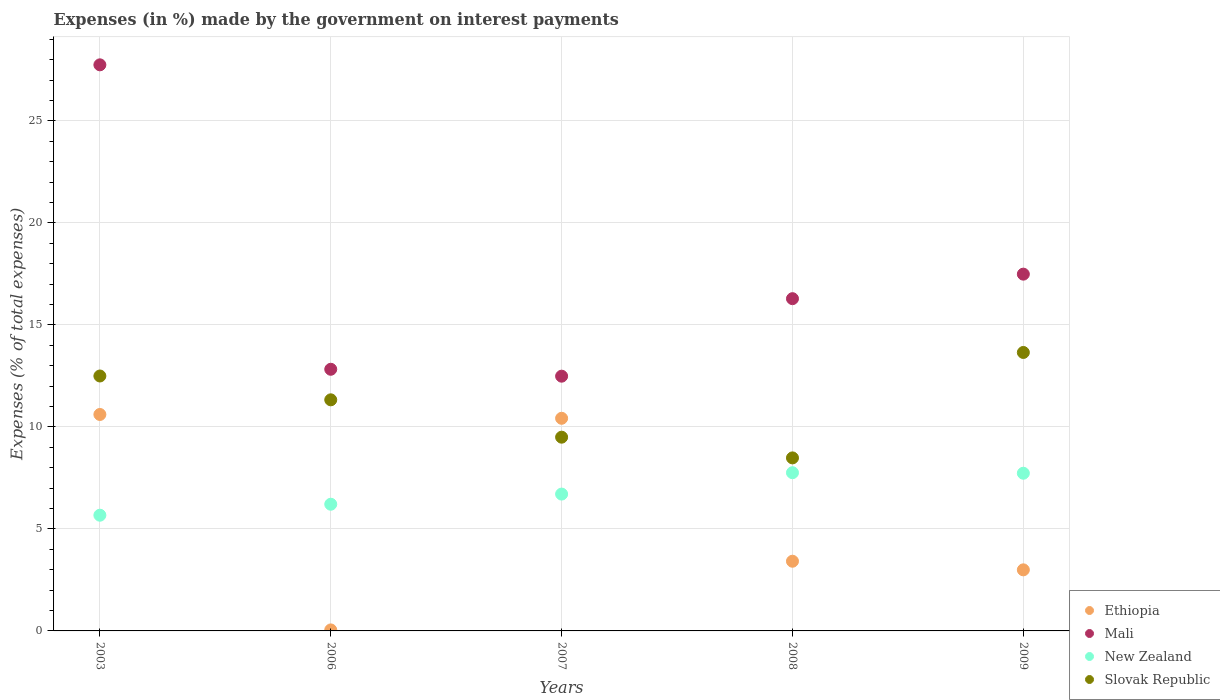What is the percentage of expenses made by the government on interest payments in New Zealand in 2003?
Offer a very short reply. 5.67. Across all years, what is the maximum percentage of expenses made by the government on interest payments in Slovak Republic?
Provide a short and direct response. 13.65. Across all years, what is the minimum percentage of expenses made by the government on interest payments in Mali?
Your answer should be very brief. 12.49. In which year was the percentage of expenses made by the government on interest payments in Slovak Republic maximum?
Give a very brief answer. 2009. What is the total percentage of expenses made by the government on interest payments in Ethiopia in the graph?
Give a very brief answer. 27.49. What is the difference between the percentage of expenses made by the government on interest payments in Ethiopia in 2003 and that in 2007?
Your response must be concise. 0.19. What is the difference between the percentage of expenses made by the government on interest payments in Slovak Republic in 2006 and the percentage of expenses made by the government on interest payments in Ethiopia in 2009?
Your response must be concise. 8.33. What is the average percentage of expenses made by the government on interest payments in Mali per year?
Offer a terse response. 17.37. In the year 2008, what is the difference between the percentage of expenses made by the government on interest payments in Slovak Republic and percentage of expenses made by the government on interest payments in Mali?
Make the answer very short. -7.8. In how many years, is the percentage of expenses made by the government on interest payments in Slovak Republic greater than 25 %?
Offer a terse response. 0. What is the ratio of the percentage of expenses made by the government on interest payments in Ethiopia in 2007 to that in 2009?
Your answer should be compact. 3.48. Is the percentage of expenses made by the government on interest payments in Ethiopia in 2007 less than that in 2009?
Your answer should be very brief. No. Is the difference between the percentage of expenses made by the government on interest payments in Slovak Republic in 2006 and 2008 greater than the difference between the percentage of expenses made by the government on interest payments in Mali in 2006 and 2008?
Your answer should be very brief. Yes. What is the difference between the highest and the second highest percentage of expenses made by the government on interest payments in New Zealand?
Ensure brevity in your answer.  0.03. What is the difference between the highest and the lowest percentage of expenses made by the government on interest payments in New Zealand?
Your response must be concise. 2.08. In how many years, is the percentage of expenses made by the government on interest payments in Mali greater than the average percentage of expenses made by the government on interest payments in Mali taken over all years?
Offer a terse response. 2. Is the sum of the percentage of expenses made by the government on interest payments in Ethiopia in 2003 and 2008 greater than the maximum percentage of expenses made by the government on interest payments in Mali across all years?
Your answer should be very brief. No. Is the percentage of expenses made by the government on interest payments in Ethiopia strictly less than the percentage of expenses made by the government on interest payments in Mali over the years?
Provide a short and direct response. Yes. How many years are there in the graph?
Your answer should be very brief. 5. Does the graph contain any zero values?
Ensure brevity in your answer.  No. What is the title of the graph?
Keep it short and to the point. Expenses (in %) made by the government on interest payments. Does "Low & middle income" appear as one of the legend labels in the graph?
Keep it short and to the point. No. What is the label or title of the Y-axis?
Offer a very short reply. Expenses (% of total expenses). What is the Expenses (% of total expenses) in Ethiopia in 2003?
Make the answer very short. 10.61. What is the Expenses (% of total expenses) of Mali in 2003?
Provide a succinct answer. 27.75. What is the Expenses (% of total expenses) in New Zealand in 2003?
Your answer should be compact. 5.67. What is the Expenses (% of total expenses) in Slovak Republic in 2003?
Offer a very short reply. 12.49. What is the Expenses (% of total expenses) of Ethiopia in 2006?
Give a very brief answer. 0.05. What is the Expenses (% of total expenses) of Mali in 2006?
Your response must be concise. 12.82. What is the Expenses (% of total expenses) in New Zealand in 2006?
Make the answer very short. 6.21. What is the Expenses (% of total expenses) in Slovak Republic in 2006?
Your response must be concise. 11.33. What is the Expenses (% of total expenses) in Ethiopia in 2007?
Provide a short and direct response. 10.42. What is the Expenses (% of total expenses) of Mali in 2007?
Ensure brevity in your answer.  12.49. What is the Expenses (% of total expenses) in New Zealand in 2007?
Offer a very short reply. 6.71. What is the Expenses (% of total expenses) in Slovak Republic in 2007?
Keep it short and to the point. 9.5. What is the Expenses (% of total expenses) in Ethiopia in 2008?
Your answer should be compact. 3.42. What is the Expenses (% of total expenses) in Mali in 2008?
Your response must be concise. 16.28. What is the Expenses (% of total expenses) of New Zealand in 2008?
Offer a very short reply. 7.75. What is the Expenses (% of total expenses) in Slovak Republic in 2008?
Your answer should be compact. 8.48. What is the Expenses (% of total expenses) in Ethiopia in 2009?
Offer a very short reply. 2.99. What is the Expenses (% of total expenses) in Mali in 2009?
Provide a short and direct response. 17.49. What is the Expenses (% of total expenses) of New Zealand in 2009?
Provide a short and direct response. 7.73. What is the Expenses (% of total expenses) in Slovak Republic in 2009?
Your answer should be very brief. 13.65. Across all years, what is the maximum Expenses (% of total expenses) in Ethiopia?
Make the answer very short. 10.61. Across all years, what is the maximum Expenses (% of total expenses) in Mali?
Provide a short and direct response. 27.75. Across all years, what is the maximum Expenses (% of total expenses) in New Zealand?
Give a very brief answer. 7.75. Across all years, what is the maximum Expenses (% of total expenses) in Slovak Republic?
Offer a terse response. 13.65. Across all years, what is the minimum Expenses (% of total expenses) in Ethiopia?
Ensure brevity in your answer.  0.05. Across all years, what is the minimum Expenses (% of total expenses) in Mali?
Make the answer very short. 12.49. Across all years, what is the minimum Expenses (% of total expenses) in New Zealand?
Offer a terse response. 5.67. Across all years, what is the minimum Expenses (% of total expenses) in Slovak Republic?
Keep it short and to the point. 8.48. What is the total Expenses (% of total expenses) of Ethiopia in the graph?
Offer a very short reply. 27.49. What is the total Expenses (% of total expenses) in Mali in the graph?
Your response must be concise. 86.83. What is the total Expenses (% of total expenses) of New Zealand in the graph?
Make the answer very short. 34.07. What is the total Expenses (% of total expenses) in Slovak Republic in the graph?
Provide a short and direct response. 55.44. What is the difference between the Expenses (% of total expenses) in Ethiopia in 2003 and that in 2006?
Your response must be concise. 10.56. What is the difference between the Expenses (% of total expenses) in Mali in 2003 and that in 2006?
Make the answer very short. 14.92. What is the difference between the Expenses (% of total expenses) in New Zealand in 2003 and that in 2006?
Offer a very short reply. -0.54. What is the difference between the Expenses (% of total expenses) in Slovak Republic in 2003 and that in 2006?
Your response must be concise. 1.17. What is the difference between the Expenses (% of total expenses) of Ethiopia in 2003 and that in 2007?
Offer a very short reply. 0.19. What is the difference between the Expenses (% of total expenses) in Mali in 2003 and that in 2007?
Your answer should be compact. 15.26. What is the difference between the Expenses (% of total expenses) of New Zealand in 2003 and that in 2007?
Provide a succinct answer. -1.04. What is the difference between the Expenses (% of total expenses) of Slovak Republic in 2003 and that in 2007?
Keep it short and to the point. 3. What is the difference between the Expenses (% of total expenses) of Ethiopia in 2003 and that in 2008?
Offer a very short reply. 7.19. What is the difference between the Expenses (% of total expenses) of Mali in 2003 and that in 2008?
Offer a terse response. 11.46. What is the difference between the Expenses (% of total expenses) of New Zealand in 2003 and that in 2008?
Your response must be concise. -2.08. What is the difference between the Expenses (% of total expenses) of Slovak Republic in 2003 and that in 2008?
Offer a very short reply. 4.01. What is the difference between the Expenses (% of total expenses) of Ethiopia in 2003 and that in 2009?
Keep it short and to the point. 7.62. What is the difference between the Expenses (% of total expenses) of Mali in 2003 and that in 2009?
Your response must be concise. 10.26. What is the difference between the Expenses (% of total expenses) in New Zealand in 2003 and that in 2009?
Your answer should be very brief. -2.06. What is the difference between the Expenses (% of total expenses) of Slovak Republic in 2003 and that in 2009?
Offer a very short reply. -1.15. What is the difference between the Expenses (% of total expenses) of Ethiopia in 2006 and that in 2007?
Provide a short and direct response. -10.37. What is the difference between the Expenses (% of total expenses) in Mali in 2006 and that in 2007?
Make the answer very short. 0.34. What is the difference between the Expenses (% of total expenses) in New Zealand in 2006 and that in 2007?
Give a very brief answer. -0.5. What is the difference between the Expenses (% of total expenses) of Slovak Republic in 2006 and that in 2007?
Your response must be concise. 1.83. What is the difference between the Expenses (% of total expenses) in Ethiopia in 2006 and that in 2008?
Keep it short and to the point. -3.37. What is the difference between the Expenses (% of total expenses) in Mali in 2006 and that in 2008?
Your response must be concise. -3.46. What is the difference between the Expenses (% of total expenses) of New Zealand in 2006 and that in 2008?
Ensure brevity in your answer.  -1.55. What is the difference between the Expenses (% of total expenses) of Slovak Republic in 2006 and that in 2008?
Offer a very short reply. 2.85. What is the difference between the Expenses (% of total expenses) of Ethiopia in 2006 and that in 2009?
Your answer should be compact. -2.94. What is the difference between the Expenses (% of total expenses) in Mali in 2006 and that in 2009?
Keep it short and to the point. -4.66. What is the difference between the Expenses (% of total expenses) of New Zealand in 2006 and that in 2009?
Keep it short and to the point. -1.52. What is the difference between the Expenses (% of total expenses) in Slovak Republic in 2006 and that in 2009?
Your answer should be very brief. -2.32. What is the difference between the Expenses (% of total expenses) of Ethiopia in 2007 and that in 2008?
Offer a terse response. 7.01. What is the difference between the Expenses (% of total expenses) in Mali in 2007 and that in 2008?
Provide a succinct answer. -3.8. What is the difference between the Expenses (% of total expenses) of New Zealand in 2007 and that in 2008?
Your answer should be very brief. -1.05. What is the difference between the Expenses (% of total expenses) in Ethiopia in 2007 and that in 2009?
Your answer should be very brief. 7.43. What is the difference between the Expenses (% of total expenses) in Mali in 2007 and that in 2009?
Make the answer very short. -5. What is the difference between the Expenses (% of total expenses) of New Zealand in 2007 and that in 2009?
Ensure brevity in your answer.  -1.02. What is the difference between the Expenses (% of total expenses) of Slovak Republic in 2007 and that in 2009?
Give a very brief answer. -4.15. What is the difference between the Expenses (% of total expenses) in Ethiopia in 2008 and that in 2009?
Make the answer very short. 0.42. What is the difference between the Expenses (% of total expenses) in Mali in 2008 and that in 2009?
Your answer should be compact. -1.2. What is the difference between the Expenses (% of total expenses) of New Zealand in 2008 and that in 2009?
Make the answer very short. 0.03. What is the difference between the Expenses (% of total expenses) in Slovak Republic in 2008 and that in 2009?
Offer a terse response. -5.17. What is the difference between the Expenses (% of total expenses) in Ethiopia in 2003 and the Expenses (% of total expenses) in Mali in 2006?
Offer a terse response. -2.22. What is the difference between the Expenses (% of total expenses) of Ethiopia in 2003 and the Expenses (% of total expenses) of New Zealand in 2006?
Offer a terse response. 4.4. What is the difference between the Expenses (% of total expenses) in Ethiopia in 2003 and the Expenses (% of total expenses) in Slovak Republic in 2006?
Offer a terse response. -0.72. What is the difference between the Expenses (% of total expenses) of Mali in 2003 and the Expenses (% of total expenses) of New Zealand in 2006?
Keep it short and to the point. 21.54. What is the difference between the Expenses (% of total expenses) in Mali in 2003 and the Expenses (% of total expenses) in Slovak Republic in 2006?
Your answer should be very brief. 16.42. What is the difference between the Expenses (% of total expenses) in New Zealand in 2003 and the Expenses (% of total expenses) in Slovak Republic in 2006?
Make the answer very short. -5.66. What is the difference between the Expenses (% of total expenses) in Ethiopia in 2003 and the Expenses (% of total expenses) in Mali in 2007?
Keep it short and to the point. -1.88. What is the difference between the Expenses (% of total expenses) in Ethiopia in 2003 and the Expenses (% of total expenses) in New Zealand in 2007?
Your answer should be compact. 3.9. What is the difference between the Expenses (% of total expenses) of Ethiopia in 2003 and the Expenses (% of total expenses) of Slovak Republic in 2007?
Offer a terse response. 1.11. What is the difference between the Expenses (% of total expenses) in Mali in 2003 and the Expenses (% of total expenses) in New Zealand in 2007?
Offer a very short reply. 21.04. What is the difference between the Expenses (% of total expenses) in Mali in 2003 and the Expenses (% of total expenses) in Slovak Republic in 2007?
Offer a very short reply. 18.25. What is the difference between the Expenses (% of total expenses) of New Zealand in 2003 and the Expenses (% of total expenses) of Slovak Republic in 2007?
Offer a terse response. -3.82. What is the difference between the Expenses (% of total expenses) of Ethiopia in 2003 and the Expenses (% of total expenses) of Mali in 2008?
Your response must be concise. -5.68. What is the difference between the Expenses (% of total expenses) in Ethiopia in 2003 and the Expenses (% of total expenses) in New Zealand in 2008?
Your answer should be compact. 2.85. What is the difference between the Expenses (% of total expenses) of Ethiopia in 2003 and the Expenses (% of total expenses) of Slovak Republic in 2008?
Keep it short and to the point. 2.13. What is the difference between the Expenses (% of total expenses) of Mali in 2003 and the Expenses (% of total expenses) of New Zealand in 2008?
Your answer should be compact. 19.99. What is the difference between the Expenses (% of total expenses) in Mali in 2003 and the Expenses (% of total expenses) in Slovak Republic in 2008?
Ensure brevity in your answer.  19.27. What is the difference between the Expenses (% of total expenses) of New Zealand in 2003 and the Expenses (% of total expenses) of Slovak Republic in 2008?
Your answer should be compact. -2.81. What is the difference between the Expenses (% of total expenses) in Ethiopia in 2003 and the Expenses (% of total expenses) in Mali in 2009?
Provide a succinct answer. -6.88. What is the difference between the Expenses (% of total expenses) in Ethiopia in 2003 and the Expenses (% of total expenses) in New Zealand in 2009?
Offer a very short reply. 2.88. What is the difference between the Expenses (% of total expenses) of Ethiopia in 2003 and the Expenses (% of total expenses) of Slovak Republic in 2009?
Provide a short and direct response. -3.04. What is the difference between the Expenses (% of total expenses) in Mali in 2003 and the Expenses (% of total expenses) in New Zealand in 2009?
Your answer should be very brief. 20.02. What is the difference between the Expenses (% of total expenses) in Mali in 2003 and the Expenses (% of total expenses) in Slovak Republic in 2009?
Keep it short and to the point. 14.1. What is the difference between the Expenses (% of total expenses) in New Zealand in 2003 and the Expenses (% of total expenses) in Slovak Republic in 2009?
Offer a very short reply. -7.98. What is the difference between the Expenses (% of total expenses) in Ethiopia in 2006 and the Expenses (% of total expenses) in Mali in 2007?
Your answer should be compact. -12.44. What is the difference between the Expenses (% of total expenses) of Ethiopia in 2006 and the Expenses (% of total expenses) of New Zealand in 2007?
Keep it short and to the point. -6.66. What is the difference between the Expenses (% of total expenses) in Ethiopia in 2006 and the Expenses (% of total expenses) in Slovak Republic in 2007?
Your response must be concise. -9.45. What is the difference between the Expenses (% of total expenses) in Mali in 2006 and the Expenses (% of total expenses) in New Zealand in 2007?
Your answer should be very brief. 6.12. What is the difference between the Expenses (% of total expenses) of Mali in 2006 and the Expenses (% of total expenses) of Slovak Republic in 2007?
Your response must be concise. 3.33. What is the difference between the Expenses (% of total expenses) in New Zealand in 2006 and the Expenses (% of total expenses) in Slovak Republic in 2007?
Offer a terse response. -3.29. What is the difference between the Expenses (% of total expenses) of Ethiopia in 2006 and the Expenses (% of total expenses) of Mali in 2008?
Provide a short and direct response. -16.23. What is the difference between the Expenses (% of total expenses) in Ethiopia in 2006 and the Expenses (% of total expenses) in New Zealand in 2008?
Provide a succinct answer. -7.71. What is the difference between the Expenses (% of total expenses) in Ethiopia in 2006 and the Expenses (% of total expenses) in Slovak Republic in 2008?
Provide a short and direct response. -8.43. What is the difference between the Expenses (% of total expenses) of Mali in 2006 and the Expenses (% of total expenses) of New Zealand in 2008?
Give a very brief answer. 5.07. What is the difference between the Expenses (% of total expenses) in Mali in 2006 and the Expenses (% of total expenses) in Slovak Republic in 2008?
Your answer should be very brief. 4.34. What is the difference between the Expenses (% of total expenses) of New Zealand in 2006 and the Expenses (% of total expenses) of Slovak Republic in 2008?
Keep it short and to the point. -2.27. What is the difference between the Expenses (% of total expenses) in Ethiopia in 2006 and the Expenses (% of total expenses) in Mali in 2009?
Provide a short and direct response. -17.44. What is the difference between the Expenses (% of total expenses) of Ethiopia in 2006 and the Expenses (% of total expenses) of New Zealand in 2009?
Offer a very short reply. -7.68. What is the difference between the Expenses (% of total expenses) of Ethiopia in 2006 and the Expenses (% of total expenses) of Slovak Republic in 2009?
Offer a very short reply. -13.6. What is the difference between the Expenses (% of total expenses) in Mali in 2006 and the Expenses (% of total expenses) in New Zealand in 2009?
Offer a very short reply. 5.1. What is the difference between the Expenses (% of total expenses) of Mali in 2006 and the Expenses (% of total expenses) of Slovak Republic in 2009?
Your answer should be very brief. -0.82. What is the difference between the Expenses (% of total expenses) in New Zealand in 2006 and the Expenses (% of total expenses) in Slovak Republic in 2009?
Keep it short and to the point. -7.44. What is the difference between the Expenses (% of total expenses) of Ethiopia in 2007 and the Expenses (% of total expenses) of Mali in 2008?
Give a very brief answer. -5.86. What is the difference between the Expenses (% of total expenses) in Ethiopia in 2007 and the Expenses (% of total expenses) in New Zealand in 2008?
Provide a succinct answer. 2.67. What is the difference between the Expenses (% of total expenses) in Ethiopia in 2007 and the Expenses (% of total expenses) in Slovak Republic in 2008?
Provide a succinct answer. 1.94. What is the difference between the Expenses (% of total expenses) of Mali in 2007 and the Expenses (% of total expenses) of New Zealand in 2008?
Give a very brief answer. 4.73. What is the difference between the Expenses (% of total expenses) of Mali in 2007 and the Expenses (% of total expenses) of Slovak Republic in 2008?
Provide a succinct answer. 4. What is the difference between the Expenses (% of total expenses) of New Zealand in 2007 and the Expenses (% of total expenses) of Slovak Republic in 2008?
Offer a terse response. -1.77. What is the difference between the Expenses (% of total expenses) of Ethiopia in 2007 and the Expenses (% of total expenses) of Mali in 2009?
Give a very brief answer. -7.06. What is the difference between the Expenses (% of total expenses) of Ethiopia in 2007 and the Expenses (% of total expenses) of New Zealand in 2009?
Offer a terse response. 2.69. What is the difference between the Expenses (% of total expenses) in Ethiopia in 2007 and the Expenses (% of total expenses) in Slovak Republic in 2009?
Your answer should be compact. -3.23. What is the difference between the Expenses (% of total expenses) of Mali in 2007 and the Expenses (% of total expenses) of New Zealand in 2009?
Your response must be concise. 4.76. What is the difference between the Expenses (% of total expenses) of Mali in 2007 and the Expenses (% of total expenses) of Slovak Republic in 2009?
Ensure brevity in your answer.  -1.16. What is the difference between the Expenses (% of total expenses) in New Zealand in 2007 and the Expenses (% of total expenses) in Slovak Republic in 2009?
Your answer should be compact. -6.94. What is the difference between the Expenses (% of total expenses) in Ethiopia in 2008 and the Expenses (% of total expenses) in Mali in 2009?
Your response must be concise. -14.07. What is the difference between the Expenses (% of total expenses) in Ethiopia in 2008 and the Expenses (% of total expenses) in New Zealand in 2009?
Your response must be concise. -4.31. What is the difference between the Expenses (% of total expenses) in Ethiopia in 2008 and the Expenses (% of total expenses) in Slovak Republic in 2009?
Give a very brief answer. -10.23. What is the difference between the Expenses (% of total expenses) of Mali in 2008 and the Expenses (% of total expenses) of New Zealand in 2009?
Give a very brief answer. 8.56. What is the difference between the Expenses (% of total expenses) of Mali in 2008 and the Expenses (% of total expenses) of Slovak Republic in 2009?
Offer a terse response. 2.64. What is the difference between the Expenses (% of total expenses) of New Zealand in 2008 and the Expenses (% of total expenses) of Slovak Republic in 2009?
Give a very brief answer. -5.89. What is the average Expenses (% of total expenses) in Ethiopia per year?
Make the answer very short. 5.5. What is the average Expenses (% of total expenses) of Mali per year?
Your response must be concise. 17.36. What is the average Expenses (% of total expenses) of New Zealand per year?
Your response must be concise. 6.81. What is the average Expenses (% of total expenses) of Slovak Republic per year?
Make the answer very short. 11.09. In the year 2003, what is the difference between the Expenses (% of total expenses) of Ethiopia and Expenses (% of total expenses) of Mali?
Provide a short and direct response. -17.14. In the year 2003, what is the difference between the Expenses (% of total expenses) of Ethiopia and Expenses (% of total expenses) of New Zealand?
Offer a very short reply. 4.94. In the year 2003, what is the difference between the Expenses (% of total expenses) of Ethiopia and Expenses (% of total expenses) of Slovak Republic?
Your answer should be compact. -1.89. In the year 2003, what is the difference between the Expenses (% of total expenses) in Mali and Expenses (% of total expenses) in New Zealand?
Offer a very short reply. 22.07. In the year 2003, what is the difference between the Expenses (% of total expenses) in Mali and Expenses (% of total expenses) in Slovak Republic?
Your response must be concise. 15.25. In the year 2003, what is the difference between the Expenses (% of total expenses) in New Zealand and Expenses (% of total expenses) in Slovak Republic?
Offer a very short reply. -6.82. In the year 2006, what is the difference between the Expenses (% of total expenses) of Ethiopia and Expenses (% of total expenses) of Mali?
Provide a succinct answer. -12.77. In the year 2006, what is the difference between the Expenses (% of total expenses) of Ethiopia and Expenses (% of total expenses) of New Zealand?
Ensure brevity in your answer.  -6.16. In the year 2006, what is the difference between the Expenses (% of total expenses) in Ethiopia and Expenses (% of total expenses) in Slovak Republic?
Make the answer very short. -11.28. In the year 2006, what is the difference between the Expenses (% of total expenses) in Mali and Expenses (% of total expenses) in New Zealand?
Ensure brevity in your answer.  6.61. In the year 2006, what is the difference between the Expenses (% of total expenses) in Mali and Expenses (% of total expenses) in Slovak Republic?
Provide a succinct answer. 1.5. In the year 2006, what is the difference between the Expenses (% of total expenses) of New Zealand and Expenses (% of total expenses) of Slovak Republic?
Your answer should be very brief. -5.12. In the year 2007, what is the difference between the Expenses (% of total expenses) of Ethiopia and Expenses (% of total expenses) of Mali?
Make the answer very short. -2.06. In the year 2007, what is the difference between the Expenses (% of total expenses) in Ethiopia and Expenses (% of total expenses) in New Zealand?
Ensure brevity in your answer.  3.71. In the year 2007, what is the difference between the Expenses (% of total expenses) of Ethiopia and Expenses (% of total expenses) of Slovak Republic?
Your answer should be compact. 0.93. In the year 2007, what is the difference between the Expenses (% of total expenses) in Mali and Expenses (% of total expenses) in New Zealand?
Offer a very short reply. 5.78. In the year 2007, what is the difference between the Expenses (% of total expenses) in Mali and Expenses (% of total expenses) in Slovak Republic?
Provide a short and direct response. 2.99. In the year 2007, what is the difference between the Expenses (% of total expenses) of New Zealand and Expenses (% of total expenses) of Slovak Republic?
Keep it short and to the point. -2.79. In the year 2008, what is the difference between the Expenses (% of total expenses) in Ethiopia and Expenses (% of total expenses) in Mali?
Offer a terse response. -12.87. In the year 2008, what is the difference between the Expenses (% of total expenses) of Ethiopia and Expenses (% of total expenses) of New Zealand?
Make the answer very short. -4.34. In the year 2008, what is the difference between the Expenses (% of total expenses) of Ethiopia and Expenses (% of total expenses) of Slovak Republic?
Your answer should be very brief. -5.06. In the year 2008, what is the difference between the Expenses (% of total expenses) of Mali and Expenses (% of total expenses) of New Zealand?
Keep it short and to the point. 8.53. In the year 2008, what is the difference between the Expenses (% of total expenses) of Mali and Expenses (% of total expenses) of Slovak Republic?
Offer a very short reply. 7.8. In the year 2008, what is the difference between the Expenses (% of total expenses) of New Zealand and Expenses (% of total expenses) of Slovak Republic?
Your answer should be very brief. -0.73. In the year 2009, what is the difference between the Expenses (% of total expenses) of Ethiopia and Expenses (% of total expenses) of Mali?
Ensure brevity in your answer.  -14.49. In the year 2009, what is the difference between the Expenses (% of total expenses) in Ethiopia and Expenses (% of total expenses) in New Zealand?
Provide a short and direct response. -4.74. In the year 2009, what is the difference between the Expenses (% of total expenses) of Ethiopia and Expenses (% of total expenses) of Slovak Republic?
Ensure brevity in your answer.  -10.65. In the year 2009, what is the difference between the Expenses (% of total expenses) of Mali and Expenses (% of total expenses) of New Zealand?
Keep it short and to the point. 9.76. In the year 2009, what is the difference between the Expenses (% of total expenses) in Mali and Expenses (% of total expenses) in Slovak Republic?
Provide a succinct answer. 3.84. In the year 2009, what is the difference between the Expenses (% of total expenses) of New Zealand and Expenses (% of total expenses) of Slovak Republic?
Ensure brevity in your answer.  -5.92. What is the ratio of the Expenses (% of total expenses) of Ethiopia in 2003 to that in 2006?
Provide a short and direct response. 215.98. What is the ratio of the Expenses (% of total expenses) of Mali in 2003 to that in 2006?
Offer a terse response. 2.16. What is the ratio of the Expenses (% of total expenses) of New Zealand in 2003 to that in 2006?
Ensure brevity in your answer.  0.91. What is the ratio of the Expenses (% of total expenses) of Slovak Republic in 2003 to that in 2006?
Ensure brevity in your answer.  1.1. What is the ratio of the Expenses (% of total expenses) in Ethiopia in 2003 to that in 2007?
Give a very brief answer. 1.02. What is the ratio of the Expenses (% of total expenses) of Mali in 2003 to that in 2007?
Offer a very short reply. 2.22. What is the ratio of the Expenses (% of total expenses) in New Zealand in 2003 to that in 2007?
Provide a short and direct response. 0.85. What is the ratio of the Expenses (% of total expenses) of Slovak Republic in 2003 to that in 2007?
Your response must be concise. 1.32. What is the ratio of the Expenses (% of total expenses) in Ethiopia in 2003 to that in 2008?
Your answer should be very brief. 3.11. What is the ratio of the Expenses (% of total expenses) in Mali in 2003 to that in 2008?
Ensure brevity in your answer.  1.7. What is the ratio of the Expenses (% of total expenses) of New Zealand in 2003 to that in 2008?
Provide a short and direct response. 0.73. What is the ratio of the Expenses (% of total expenses) of Slovak Republic in 2003 to that in 2008?
Your answer should be very brief. 1.47. What is the ratio of the Expenses (% of total expenses) in Ethiopia in 2003 to that in 2009?
Provide a short and direct response. 3.54. What is the ratio of the Expenses (% of total expenses) of Mali in 2003 to that in 2009?
Give a very brief answer. 1.59. What is the ratio of the Expenses (% of total expenses) in New Zealand in 2003 to that in 2009?
Make the answer very short. 0.73. What is the ratio of the Expenses (% of total expenses) of Slovak Republic in 2003 to that in 2009?
Provide a short and direct response. 0.92. What is the ratio of the Expenses (% of total expenses) in Ethiopia in 2006 to that in 2007?
Provide a succinct answer. 0. What is the ratio of the Expenses (% of total expenses) of Mali in 2006 to that in 2007?
Offer a very short reply. 1.03. What is the ratio of the Expenses (% of total expenses) of New Zealand in 2006 to that in 2007?
Provide a succinct answer. 0.93. What is the ratio of the Expenses (% of total expenses) in Slovak Republic in 2006 to that in 2007?
Offer a terse response. 1.19. What is the ratio of the Expenses (% of total expenses) in Ethiopia in 2006 to that in 2008?
Your answer should be compact. 0.01. What is the ratio of the Expenses (% of total expenses) in Mali in 2006 to that in 2008?
Keep it short and to the point. 0.79. What is the ratio of the Expenses (% of total expenses) of New Zealand in 2006 to that in 2008?
Make the answer very short. 0.8. What is the ratio of the Expenses (% of total expenses) in Slovak Republic in 2006 to that in 2008?
Give a very brief answer. 1.34. What is the ratio of the Expenses (% of total expenses) in Ethiopia in 2006 to that in 2009?
Your answer should be compact. 0.02. What is the ratio of the Expenses (% of total expenses) in Mali in 2006 to that in 2009?
Provide a short and direct response. 0.73. What is the ratio of the Expenses (% of total expenses) in New Zealand in 2006 to that in 2009?
Your answer should be compact. 0.8. What is the ratio of the Expenses (% of total expenses) of Slovak Republic in 2006 to that in 2009?
Your answer should be very brief. 0.83. What is the ratio of the Expenses (% of total expenses) of Ethiopia in 2007 to that in 2008?
Give a very brief answer. 3.05. What is the ratio of the Expenses (% of total expenses) of Mali in 2007 to that in 2008?
Keep it short and to the point. 0.77. What is the ratio of the Expenses (% of total expenses) of New Zealand in 2007 to that in 2008?
Your answer should be compact. 0.86. What is the ratio of the Expenses (% of total expenses) of Slovak Republic in 2007 to that in 2008?
Your answer should be compact. 1.12. What is the ratio of the Expenses (% of total expenses) of Ethiopia in 2007 to that in 2009?
Offer a terse response. 3.48. What is the ratio of the Expenses (% of total expenses) in Mali in 2007 to that in 2009?
Your answer should be very brief. 0.71. What is the ratio of the Expenses (% of total expenses) in New Zealand in 2007 to that in 2009?
Provide a succinct answer. 0.87. What is the ratio of the Expenses (% of total expenses) of Slovak Republic in 2007 to that in 2009?
Ensure brevity in your answer.  0.7. What is the ratio of the Expenses (% of total expenses) of Ethiopia in 2008 to that in 2009?
Your response must be concise. 1.14. What is the ratio of the Expenses (% of total expenses) in Mali in 2008 to that in 2009?
Your response must be concise. 0.93. What is the ratio of the Expenses (% of total expenses) of New Zealand in 2008 to that in 2009?
Provide a short and direct response. 1. What is the ratio of the Expenses (% of total expenses) of Slovak Republic in 2008 to that in 2009?
Your response must be concise. 0.62. What is the difference between the highest and the second highest Expenses (% of total expenses) of Ethiopia?
Offer a terse response. 0.19. What is the difference between the highest and the second highest Expenses (% of total expenses) in Mali?
Provide a succinct answer. 10.26. What is the difference between the highest and the second highest Expenses (% of total expenses) in New Zealand?
Provide a short and direct response. 0.03. What is the difference between the highest and the second highest Expenses (% of total expenses) of Slovak Republic?
Make the answer very short. 1.15. What is the difference between the highest and the lowest Expenses (% of total expenses) in Ethiopia?
Your answer should be compact. 10.56. What is the difference between the highest and the lowest Expenses (% of total expenses) in Mali?
Ensure brevity in your answer.  15.26. What is the difference between the highest and the lowest Expenses (% of total expenses) of New Zealand?
Provide a short and direct response. 2.08. What is the difference between the highest and the lowest Expenses (% of total expenses) of Slovak Republic?
Keep it short and to the point. 5.17. 